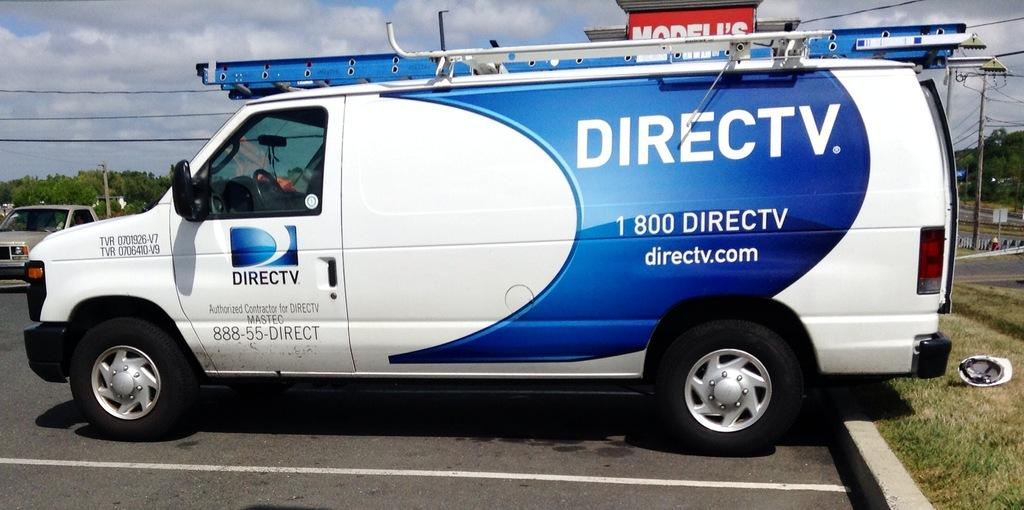<image>
Summarize the visual content of the image. Blue and white van which says DIRECTV on it. 